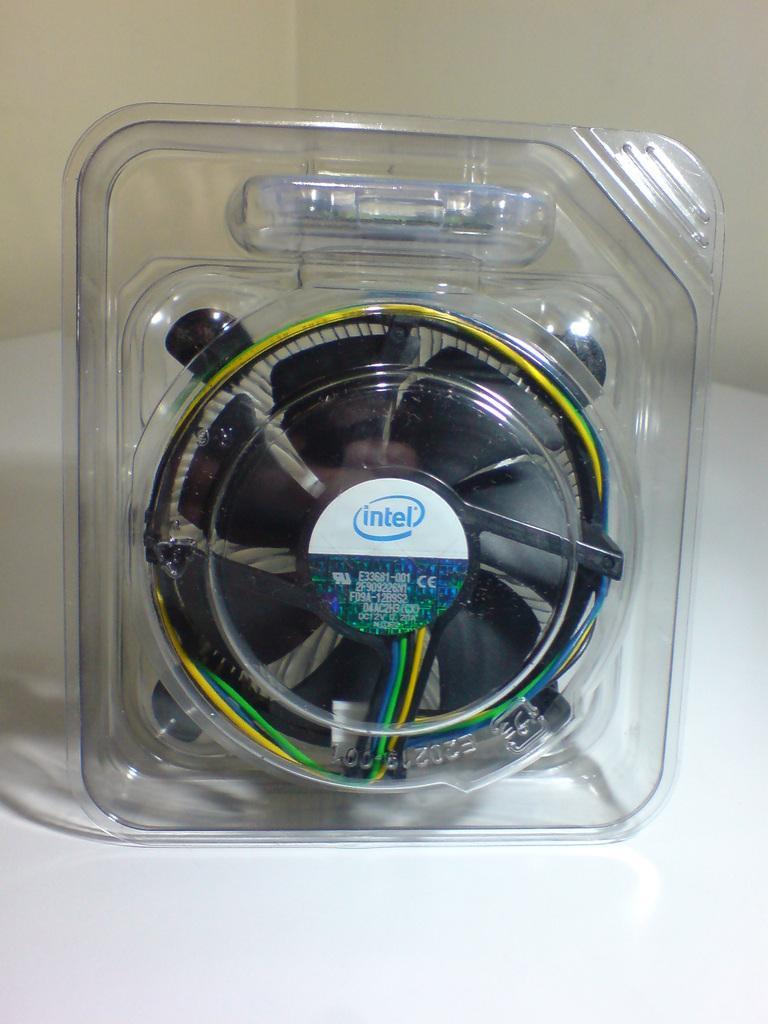Could you give a brief overview of what you see in this image? In this image I can see fan which was packed. The fan is in black color and I can see the sticker is attached to the packet. It is on the white color surface. In the background I can see the cream color wall. 